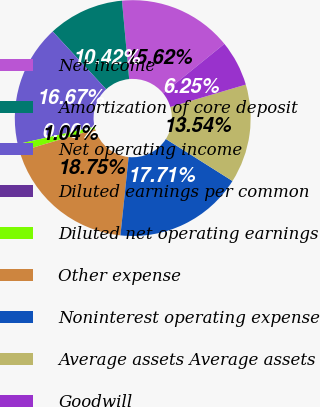Convert chart. <chart><loc_0><loc_0><loc_500><loc_500><pie_chart><fcel>Net income<fcel>Amortization of core deposit<fcel>Net operating income<fcel>Diluted earnings per common<fcel>Diluted net operating earnings<fcel>Other expense<fcel>Noninterest operating expense<fcel>Average assets Average assets<fcel>Goodwill<nl><fcel>15.62%<fcel>10.42%<fcel>16.67%<fcel>0.0%<fcel>1.04%<fcel>18.75%<fcel>17.71%<fcel>13.54%<fcel>6.25%<nl></chart> 